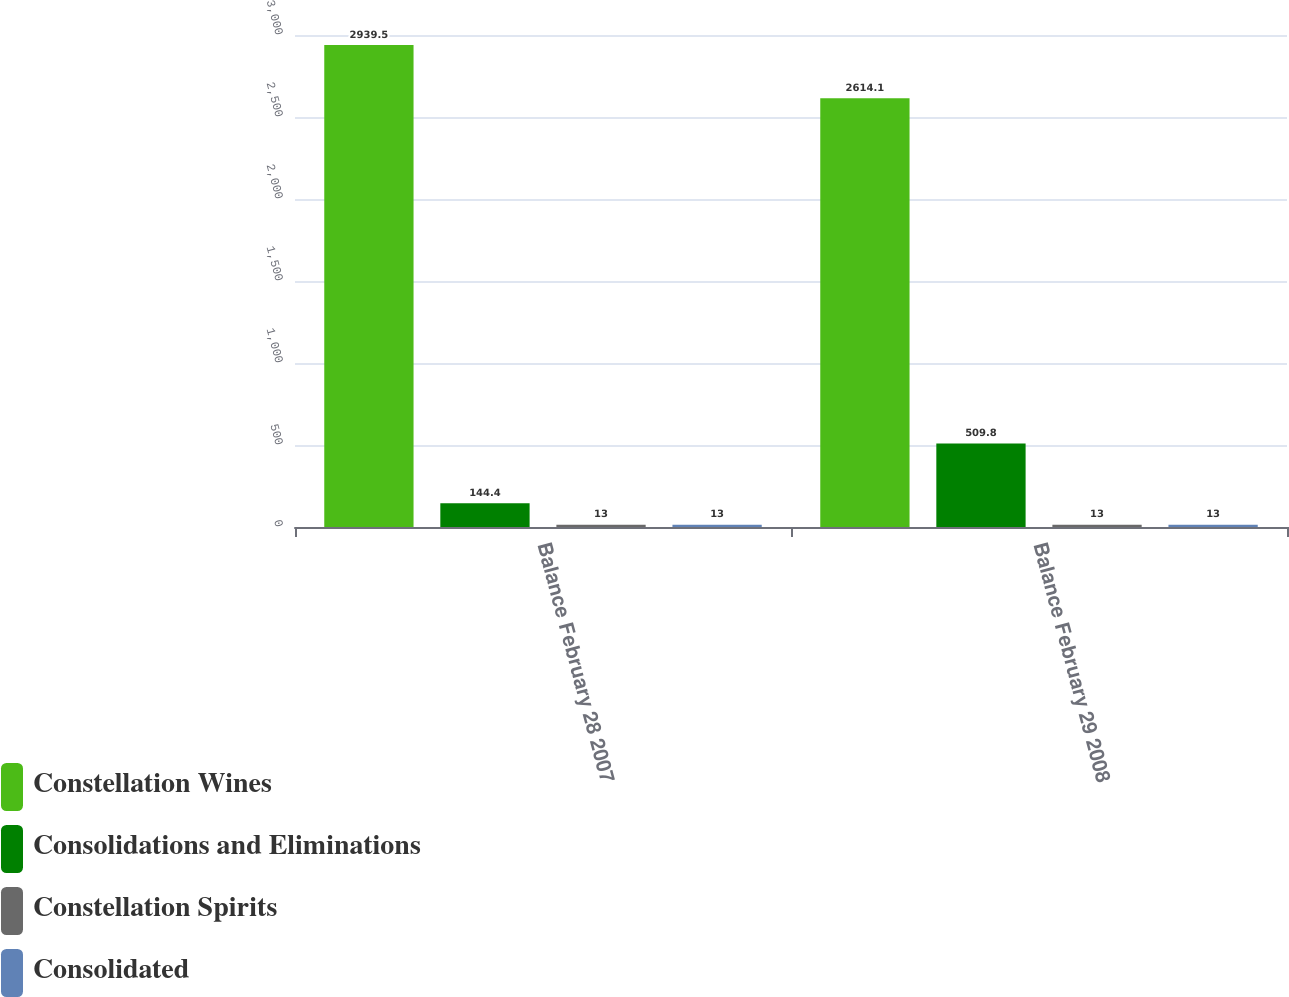Convert chart to OTSL. <chart><loc_0><loc_0><loc_500><loc_500><stacked_bar_chart><ecel><fcel>Balance February 28 2007<fcel>Balance February 29 2008<nl><fcel>Constellation Wines<fcel>2939.5<fcel>2614.1<nl><fcel>Consolidations and Eliminations<fcel>144.4<fcel>509.8<nl><fcel>Constellation Spirits<fcel>13<fcel>13<nl><fcel>Consolidated<fcel>13<fcel>13<nl></chart> 